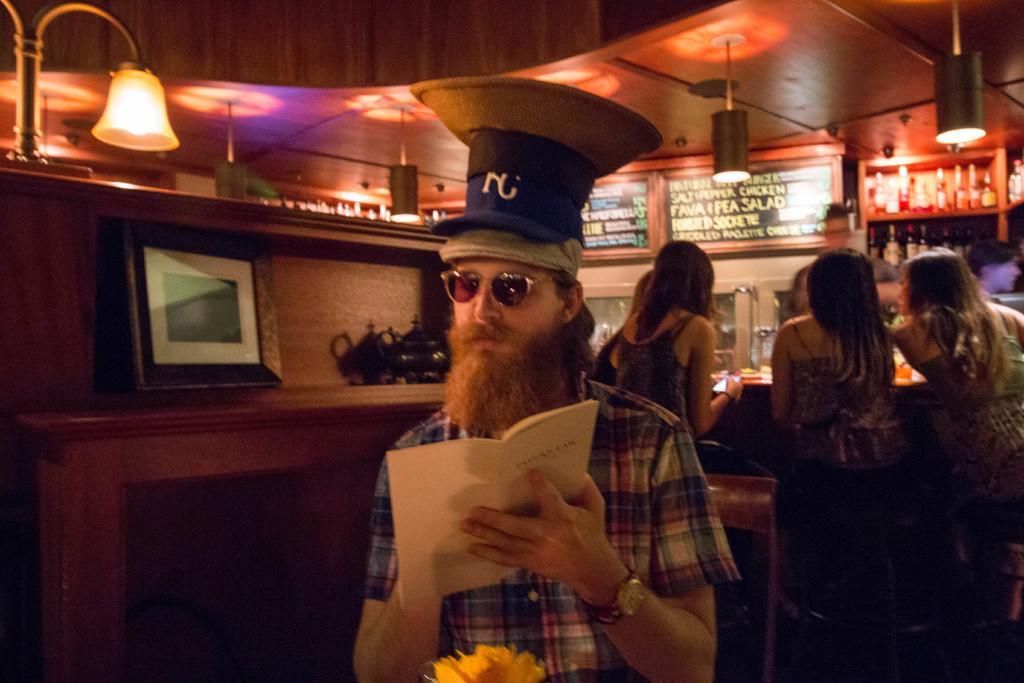How would you summarize this image in a sentence or two? This picture shows the inner view of a building. There are some lights attached to the ceiling, one photo frame on the surface, one man standing near the table, one flower on the surface, some bottles in the cupboard, four women sitting on the chairs near the table and some objects are on the table. There are some objects are on the surface, one woman holding cell phone, two boards with text attached to the wall, one man sitting on the chair and holding a book. 